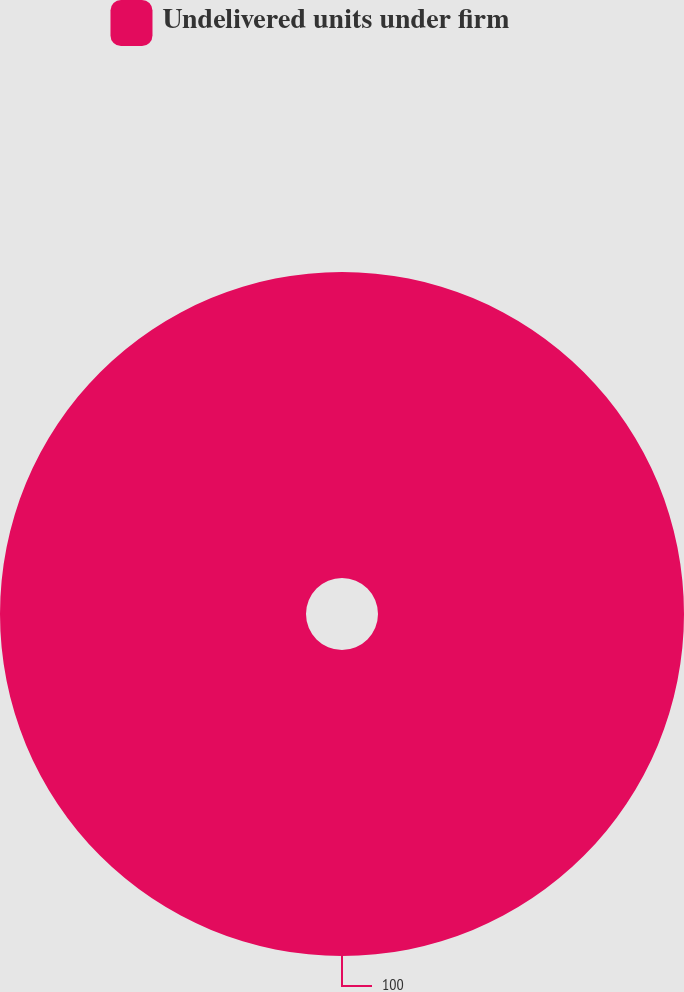Convert chart to OTSL. <chart><loc_0><loc_0><loc_500><loc_500><pie_chart><fcel>Undelivered units under firm<nl><fcel>100.0%<nl></chart> 